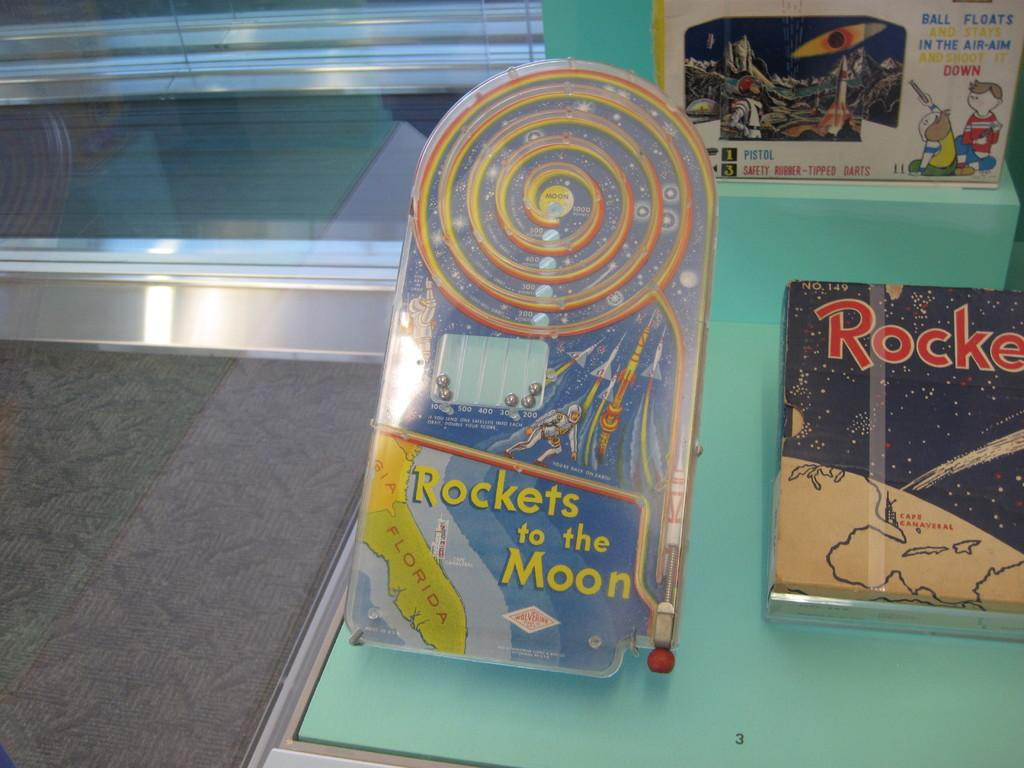<image>
Describe the image concisely. Rockets to the Moon features on an item with a spiral on it 